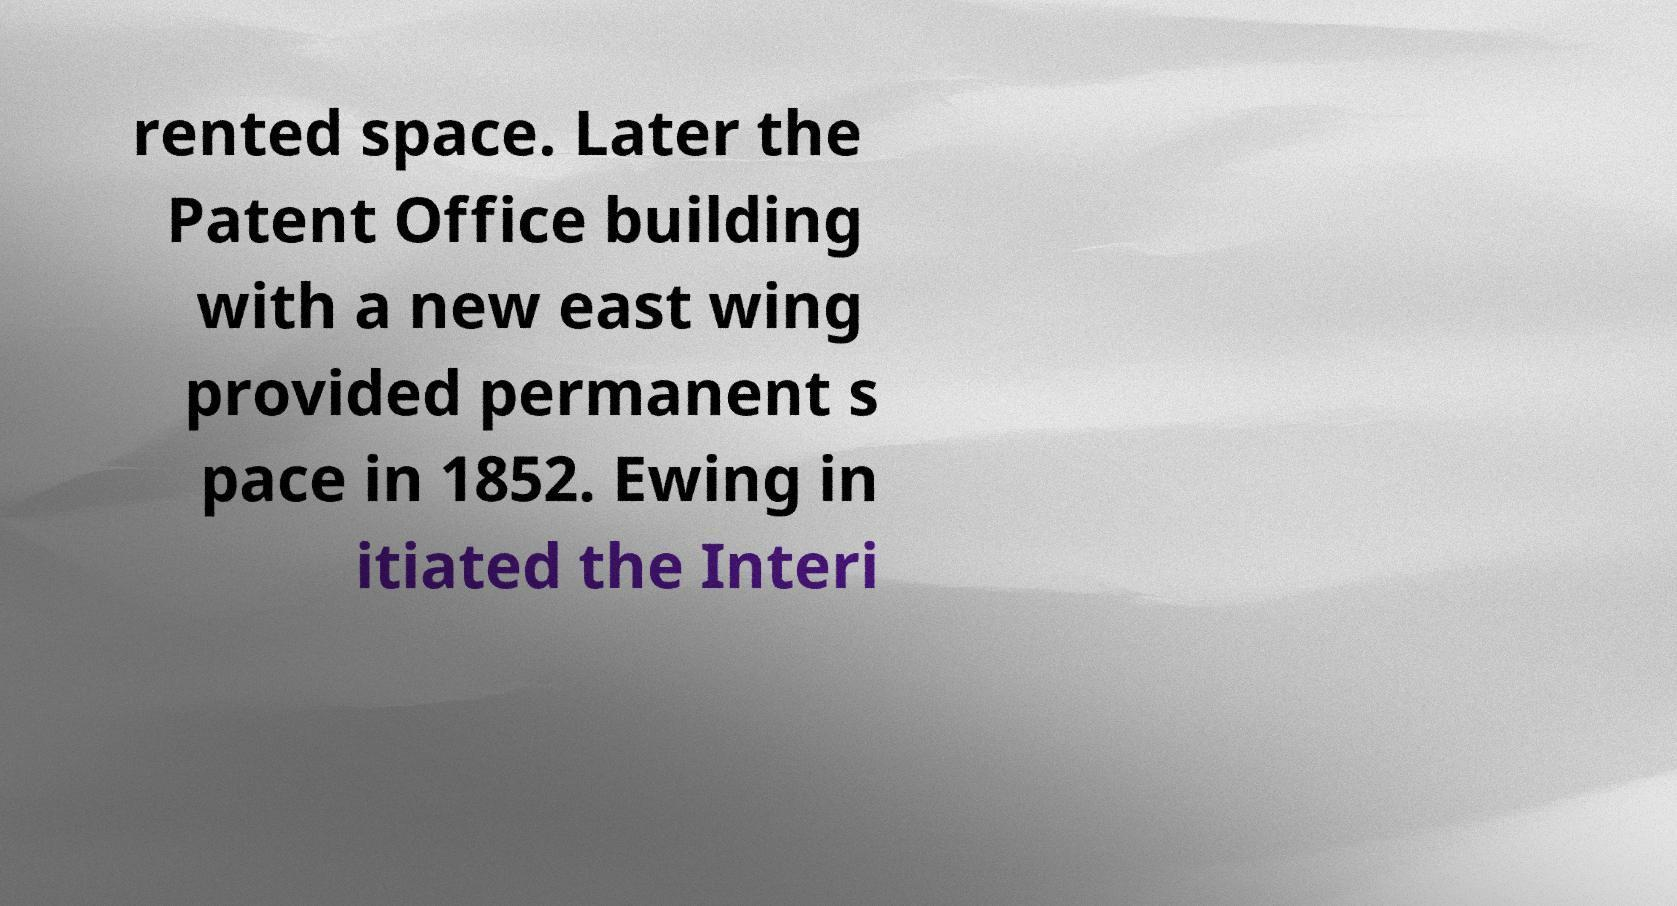For documentation purposes, I need the text within this image transcribed. Could you provide that? rented space. Later the Patent Office building with a new east wing provided permanent s pace in 1852. Ewing in itiated the Interi 